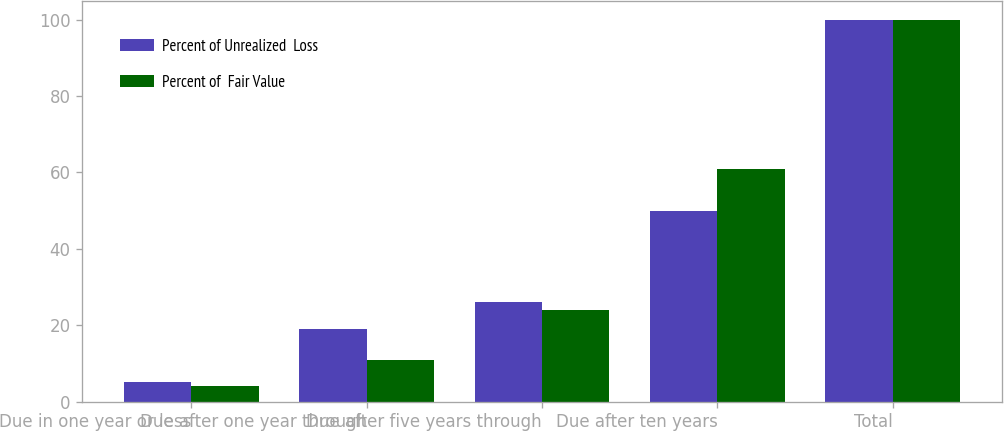Convert chart. <chart><loc_0><loc_0><loc_500><loc_500><stacked_bar_chart><ecel><fcel>Due in one year or less<fcel>Due after one year through<fcel>Due after five years through<fcel>Due after ten years<fcel>Total<nl><fcel>Percent of Unrealized  Loss<fcel>5<fcel>19<fcel>26<fcel>50<fcel>100<nl><fcel>Percent of  Fair Value<fcel>4<fcel>11<fcel>24<fcel>61<fcel>100<nl></chart> 